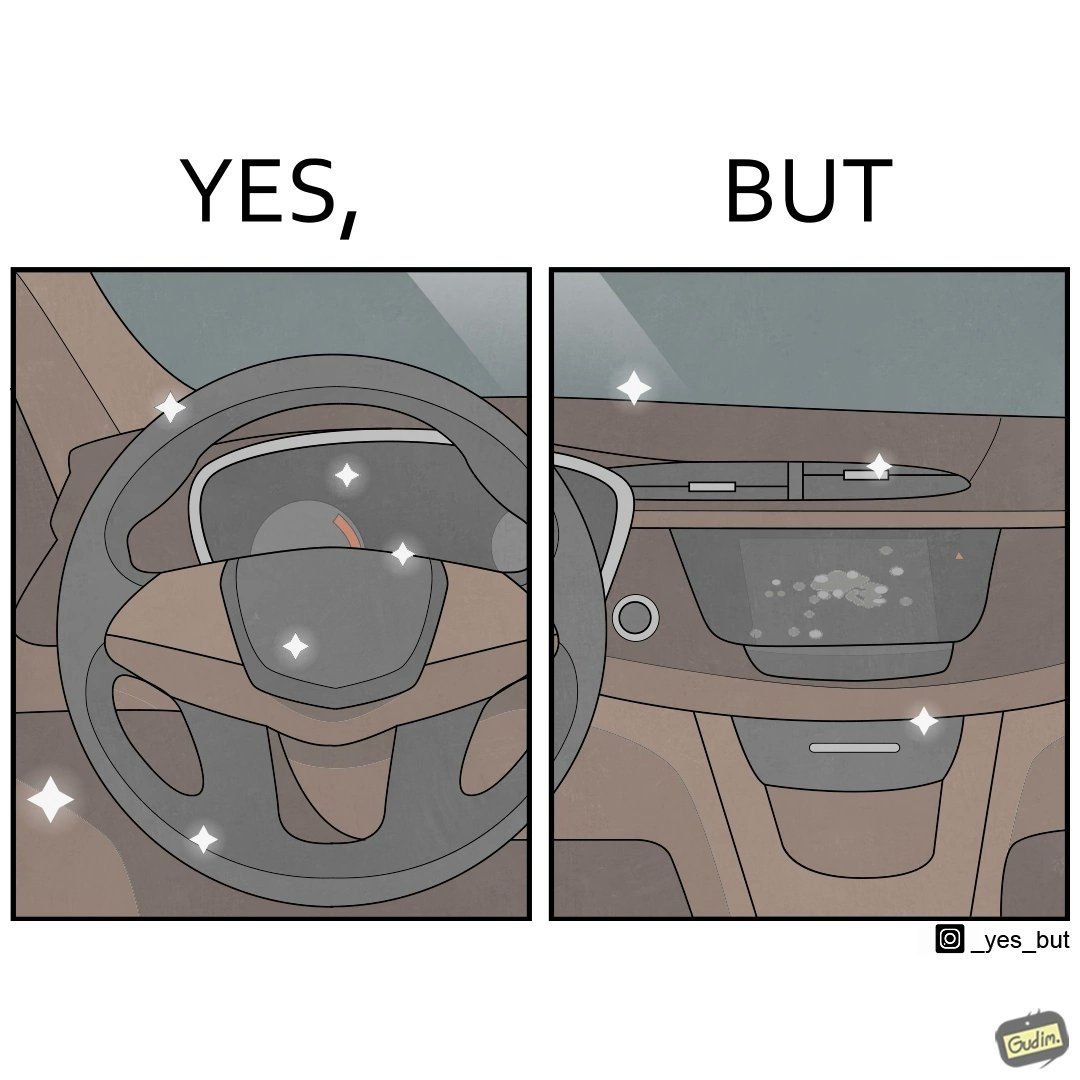Describe the content of this image. The dashboard and steering wheel of the car look sparkling clean, but the greasy fingerprints on the touch panel reduce the appeal of the dashboard. 